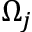Convert formula to latex. <formula><loc_0><loc_0><loc_500><loc_500>\Omega _ { j }</formula> 